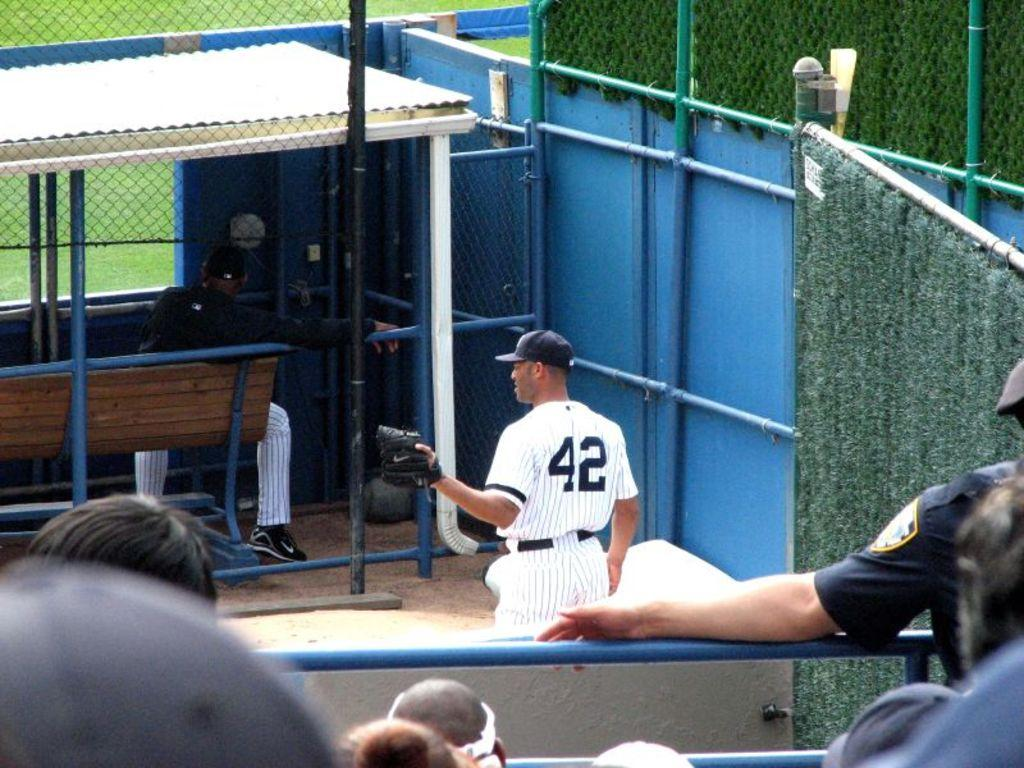<image>
Share a concise interpretation of the image provided. the number 42 is on the back of the baseball player 